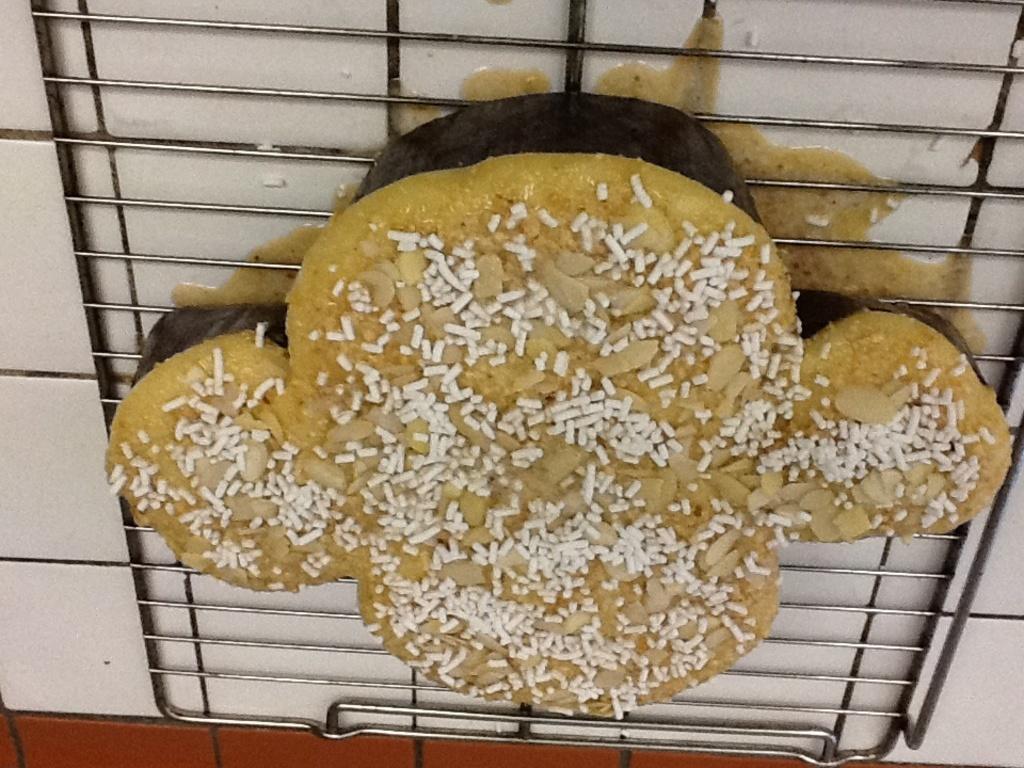How would you summarize this image in a sentence or two? In the center of the image there are food items on the grill. 